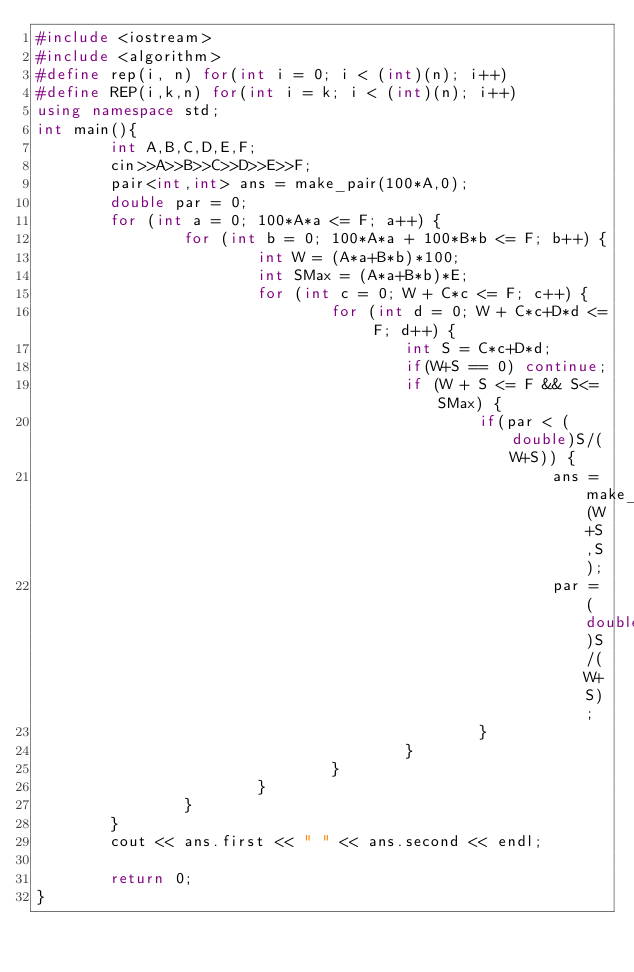Convert code to text. <code><loc_0><loc_0><loc_500><loc_500><_C++_>#include <iostream>
#include <algorithm>
#define rep(i, n) for(int i = 0; i < (int)(n); i++)
#define REP(i,k,n) for(int i = k; i < (int)(n); i++)
using namespace std;
int main(){
        int A,B,C,D,E,F;
        cin>>A>>B>>C>>D>>E>>F;
        pair<int,int> ans = make_pair(100*A,0);
        double par = 0;
        for (int a = 0; 100*A*a <= F; a++) {
                for (int b = 0; 100*A*a + 100*B*b <= F; b++) {
                        int W = (A*a+B*b)*100;
                        int SMax = (A*a+B*b)*E;
                        for (int c = 0; W + C*c <= F; c++) {
                                for (int d = 0; W + C*c+D*d <= F; d++) {
                                        int S = C*c+D*d;
                                        if(W+S == 0) continue;
                                        if (W + S <= F && S<=SMax) {
                                                if(par < (double)S/(W+S)) {
                                                        ans = make_pair(W+S,S);
                                                        par = (double)S/(W+S);
                                                }
                                        }
                                }
                        }
                }
        }
        cout << ans.first << " " << ans.second << endl;

        return 0;
}
</code> 